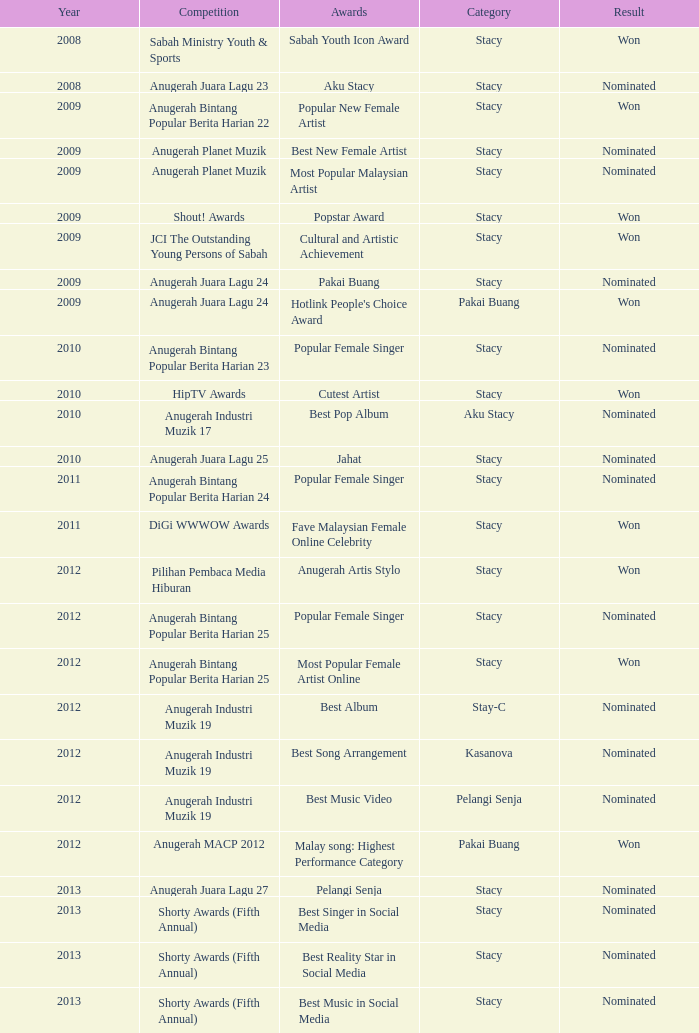What was the result in the year greaters than 2008 with an award of Jahat and had a category of Stacy? Nominated. 